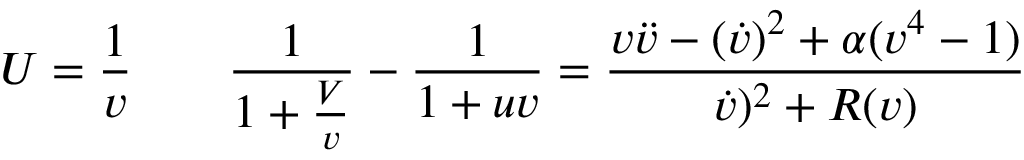<formula> <loc_0><loc_0><loc_500><loc_500>U = { \frac { 1 } { v } } \quad { \frac { 1 } { 1 + { \frac { V } { v } } } } - { \frac { 1 } { 1 + u v } } = \frac { v \ddot { v } - ( \dot { v } ) ^ { 2 } + \alpha ( v ^ { 4 } - 1 ) } { \dot { v } ) ^ { 2 } + R ( v ) }</formula> 